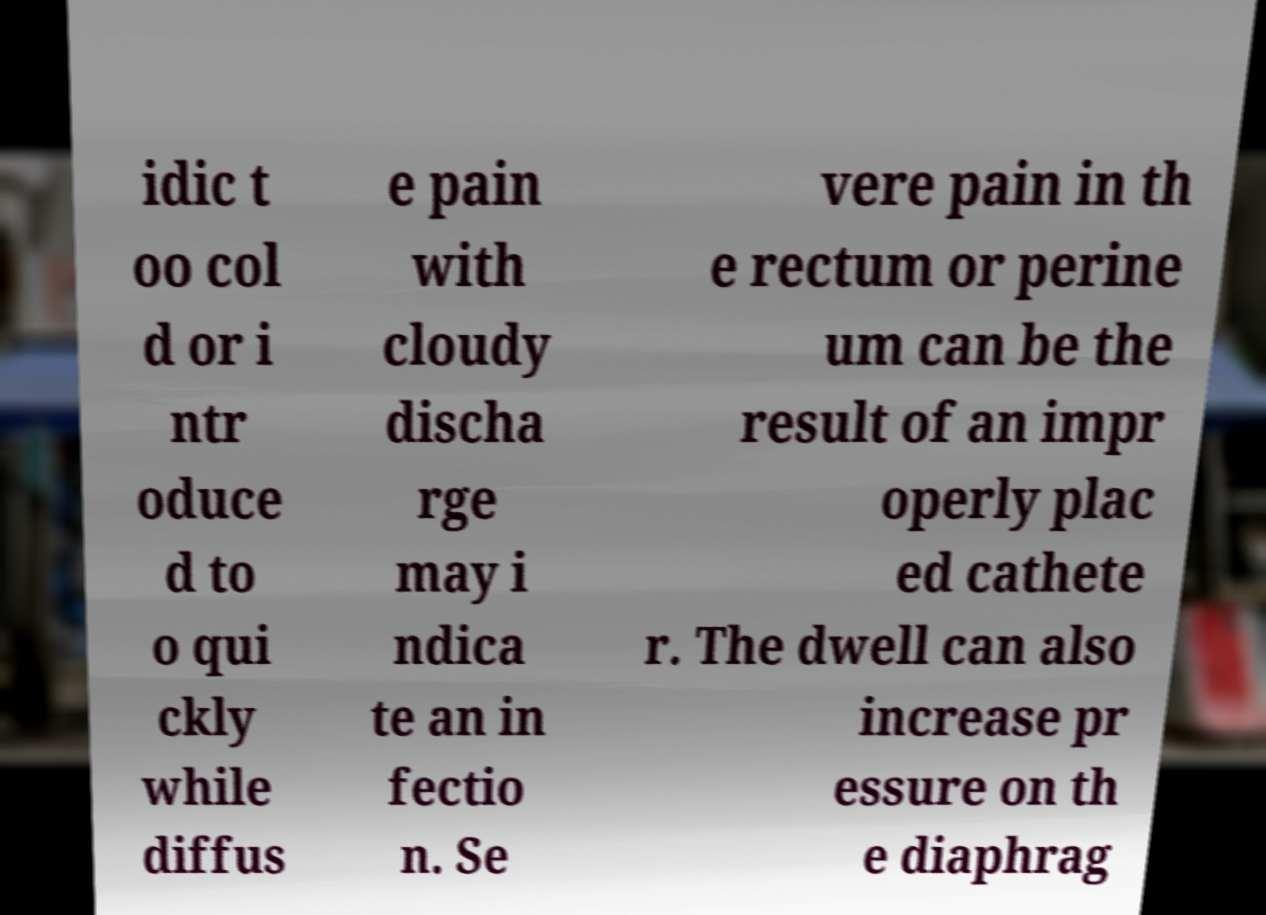For documentation purposes, I need the text within this image transcribed. Could you provide that? idic t oo col d or i ntr oduce d to o qui ckly while diffus e pain with cloudy discha rge may i ndica te an in fectio n. Se vere pain in th e rectum or perine um can be the result of an impr operly plac ed cathete r. The dwell can also increase pr essure on th e diaphrag 